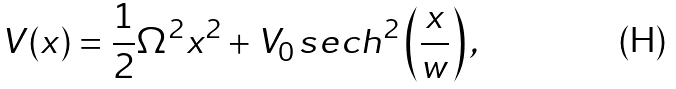<formula> <loc_0><loc_0><loc_500><loc_500>V ( x ) = \frac { 1 } { 2 } \Omega ^ { 2 } x ^ { 2 } + V _ { 0 } \, s e c h ^ { 2 } \left ( \frac { x } { w } \right ) ,</formula> 